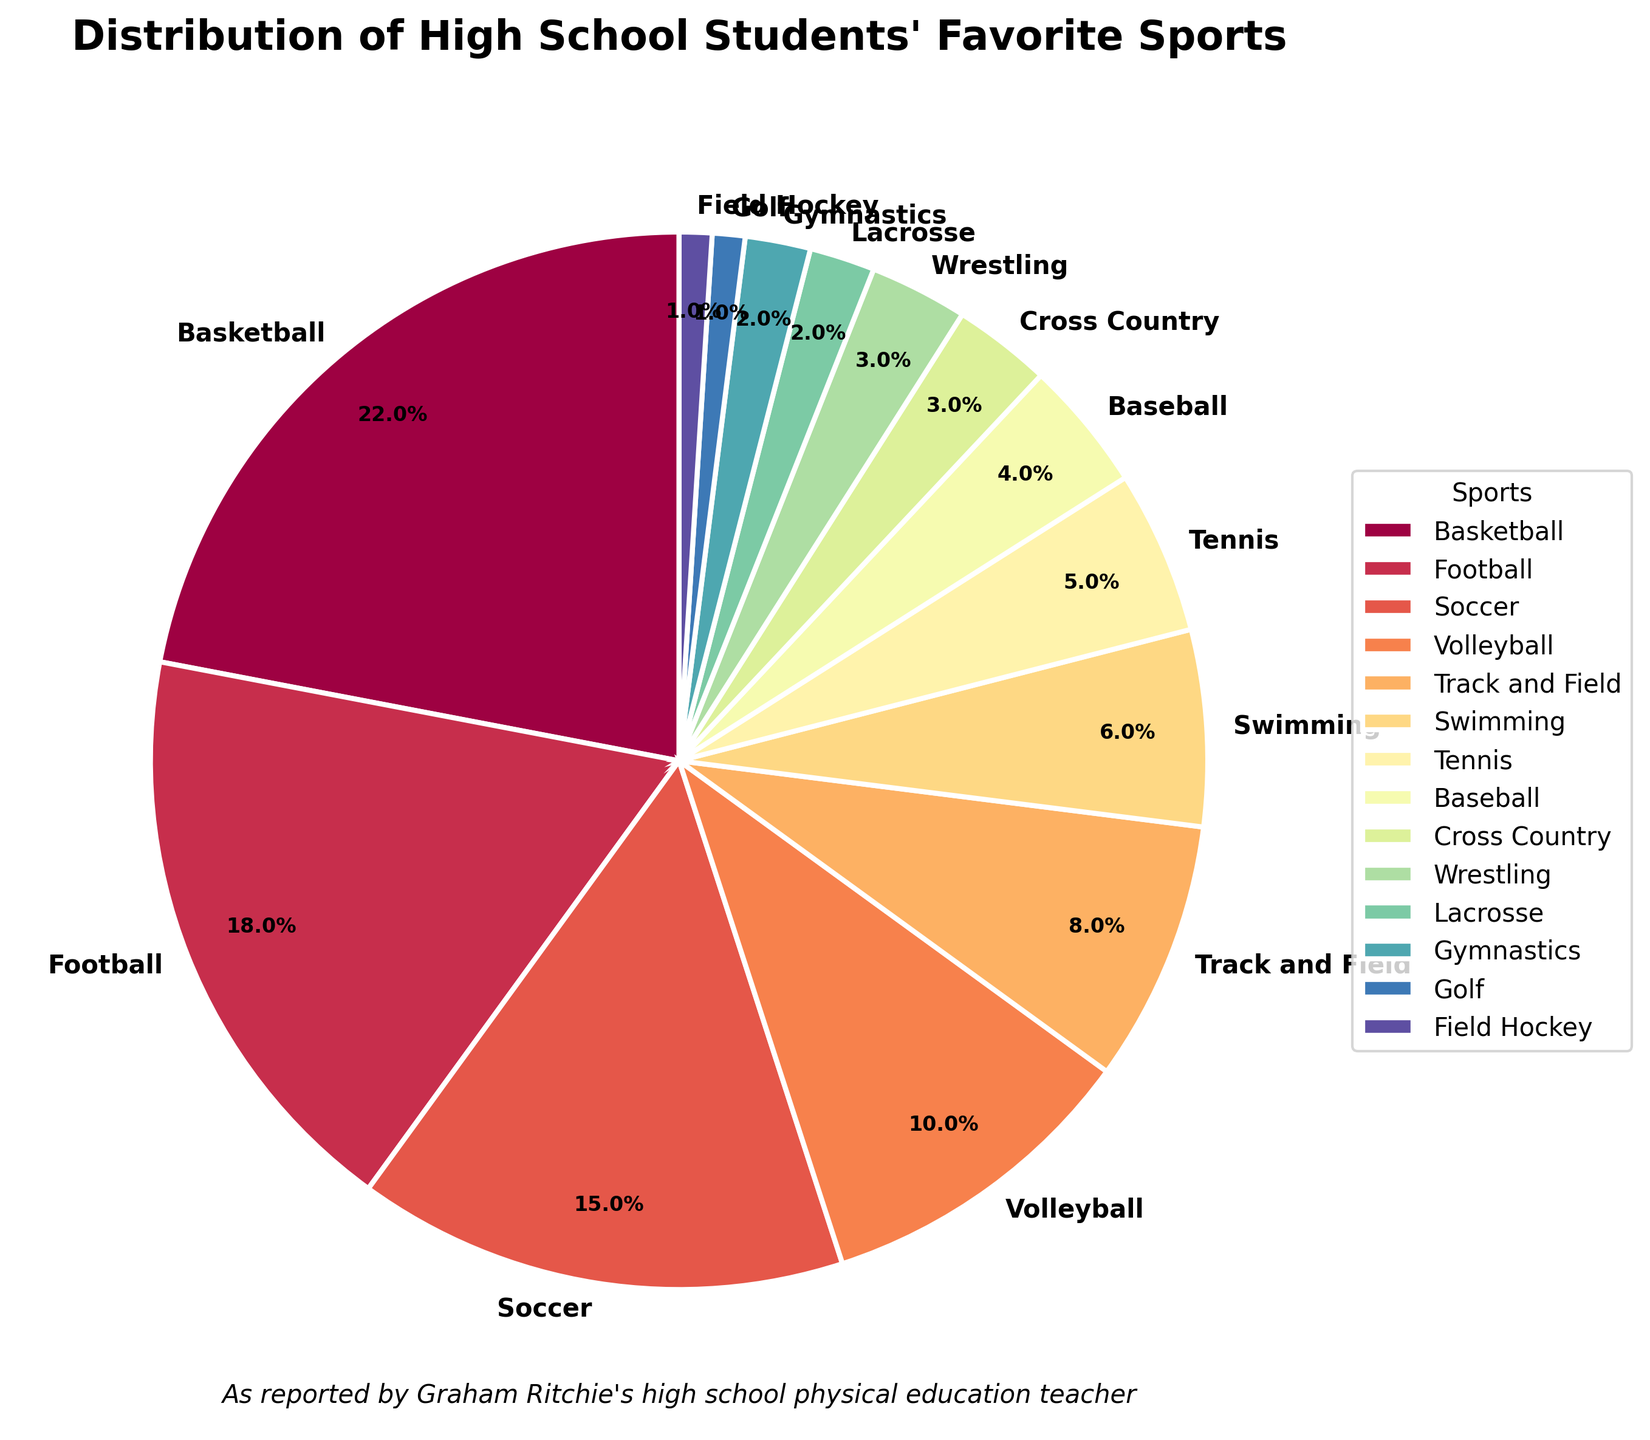Which sport has the highest percentage of students' preferences? Because the pie chart contains the percentages for each sport, you can quickly see the segment that represents the largest percentage. Look for the largest slice and its label.
Answer: Basketball Which two sports combined make up more than 40% of students' preferences? Identify the percentages of different sports and add them together until you reach a sum exceeding 40%. Basketball (22%) combined with Football (18%) gives 22% + 18% = 40%.
Answer: Basketball and Football How much more popular is Soccer compared to Baseball? Examine the pie chart for the percentages of Soccer and Baseball. Subtract the percentage of Baseball from the percentage of Soccer: 15% - 4% = 11%.
Answer: 11% Which sports have a percentage less than or equal to 5%? Check each segment for sports with 5% or lower. These are Tennis (5%), Baseball (4%), Cross Country (3%), Wrestling (3%), Lacrosse (2%), Gymnastics (2%), Golf (1%), and Field Hockey (1%).
Answer: Tennis, Baseball, Cross Country, Wrestling, Lacrosse, Gymnastics, Golf, Field Hockey How many sports have a percentage higher than 10%? Count the segments in the pie chart where the percentage is greater than 10%. The sports are Basketball (22%), Football (18%), and Soccer (15%).
Answer: 3 Which sport has the smallest percentage, and what is it? Look for the smallest segment in the pie chart and check its percentage. The sport is Field Hockey with 1%.
Answer: Field Hockey, 1% Are there any sports with an equal percentage of students' preferences? If so, which ones? Look for segments with identical percentages. Wrestling and Cross Country both have 3%, and Lacrosse and Gymnastics both have 2%.
Answer: Wrestling and Cross Country; Lacrosse and Gymnastics What is the total percentage of students who prefer swimming and tennis combined? Identify the percentages for Swimming (6%) and Tennis (5%) and add them together: 6% + 5% = 11%.
Answer: 11% How many sports have less than a 5% preference from students? Count the segments in the pie chart where the percentage is below 5%. The sports are Baseball (4%), Cross Country (3%), Wrestling (3%), Lacrosse (2%), Gymnastics (2%), Golf (1%), and Field Hockey (1%).
Answer: 7 